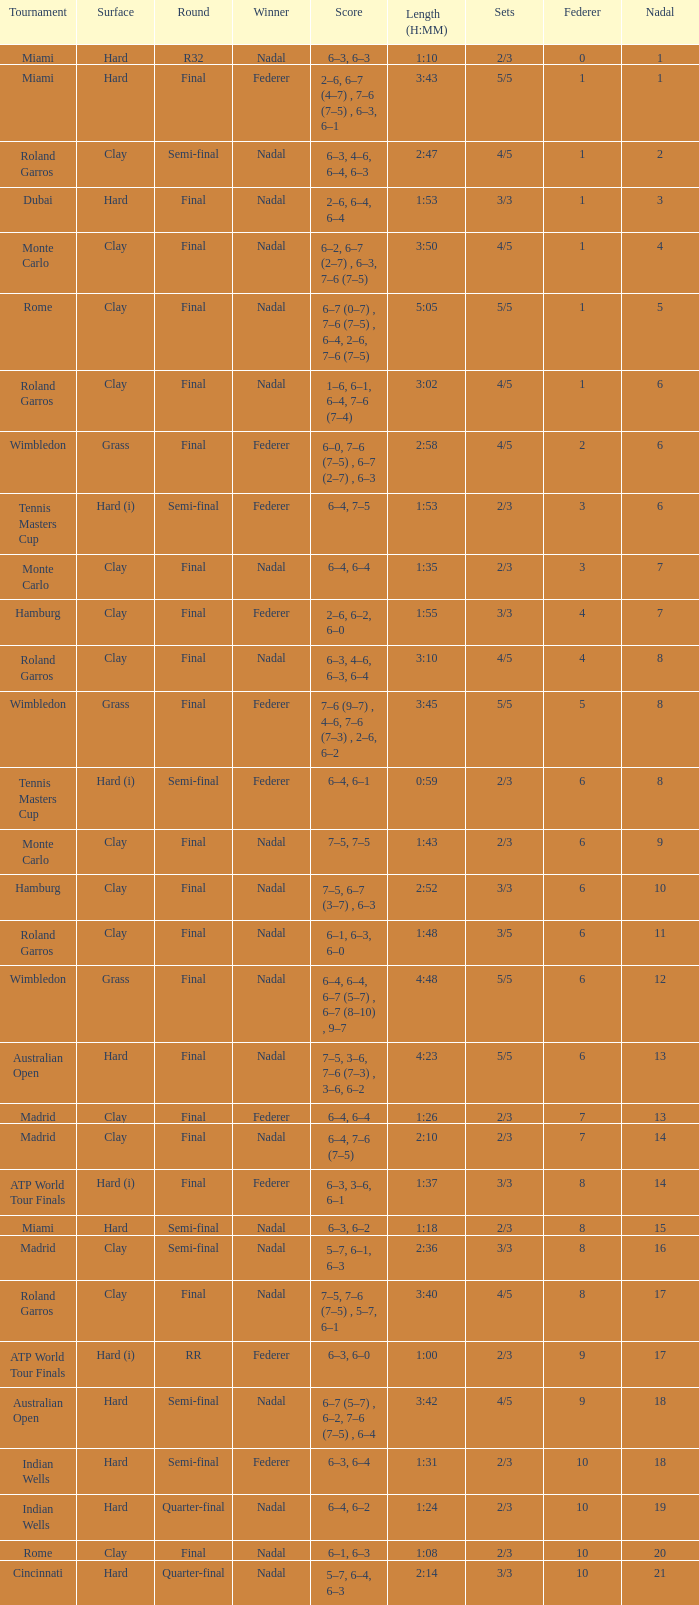Which contest did nadal succeed in and had a total of 16? Madrid. 